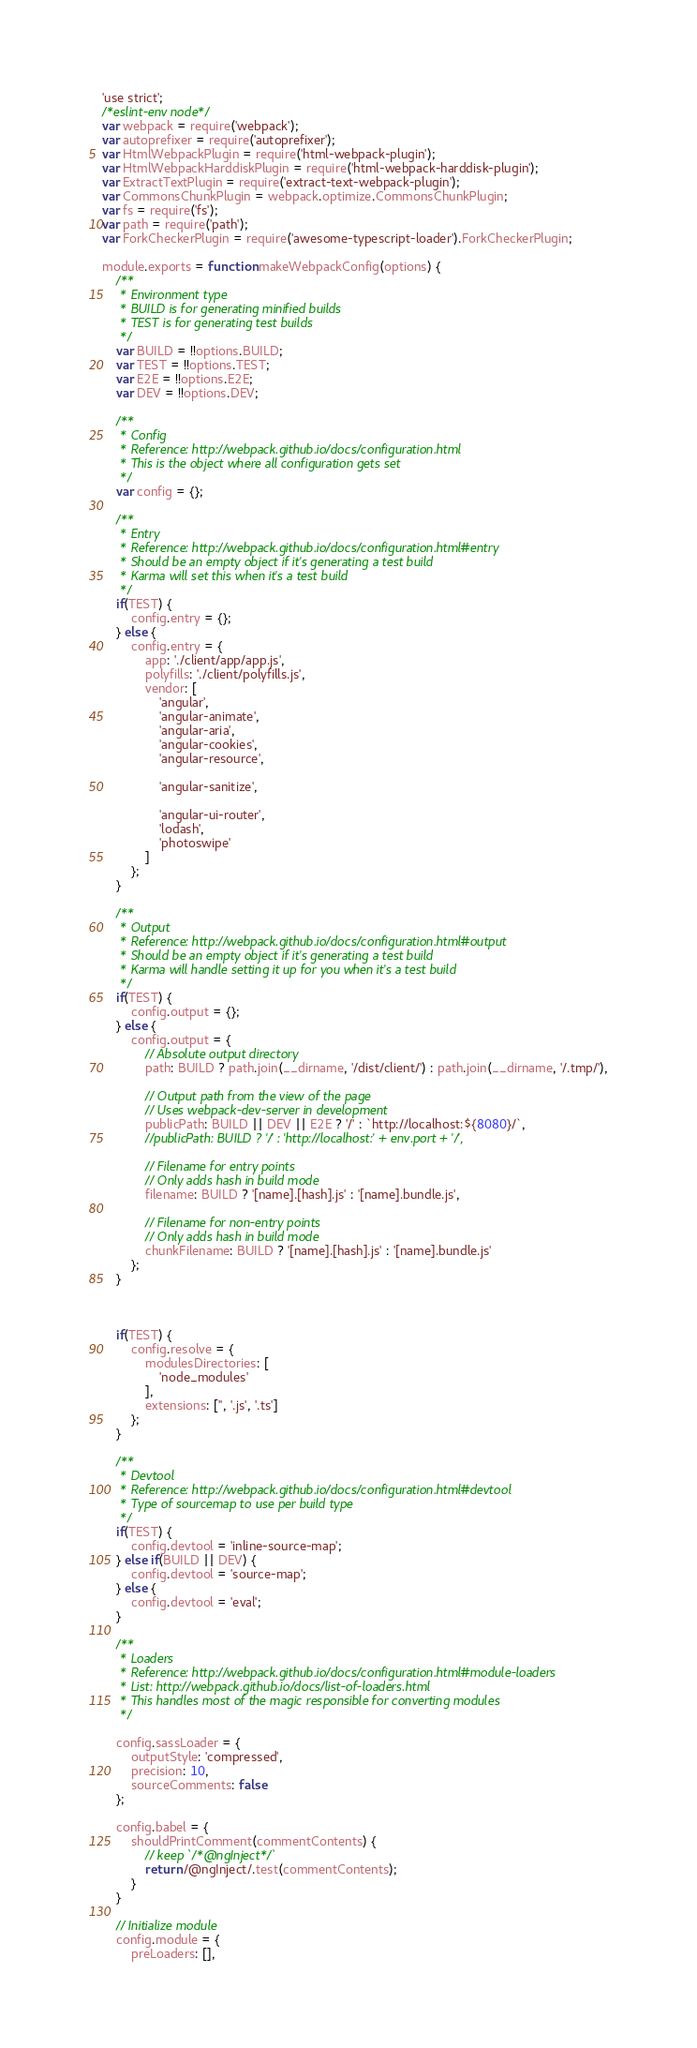Convert code to text. <code><loc_0><loc_0><loc_500><loc_500><_JavaScript_>'use strict';
/*eslint-env node*/
var webpack = require('webpack');
var autoprefixer = require('autoprefixer');
var HtmlWebpackPlugin = require('html-webpack-plugin');
var HtmlWebpackHarddiskPlugin = require('html-webpack-harddisk-plugin');
var ExtractTextPlugin = require('extract-text-webpack-plugin');
var CommonsChunkPlugin = webpack.optimize.CommonsChunkPlugin;
var fs = require('fs');
var path = require('path');
var ForkCheckerPlugin = require('awesome-typescript-loader').ForkCheckerPlugin;

module.exports = function makeWebpackConfig(options) {
    /**
     * Environment type
     * BUILD is for generating minified builds
     * TEST is for generating test builds
     */
    var BUILD = !!options.BUILD;
    var TEST = !!options.TEST;
    var E2E = !!options.E2E;
    var DEV = !!options.DEV;

    /**
     * Config
     * Reference: http://webpack.github.io/docs/configuration.html
     * This is the object where all configuration gets set
     */
    var config = {};

    /**
     * Entry
     * Reference: http://webpack.github.io/docs/configuration.html#entry
     * Should be an empty object if it's generating a test build
     * Karma will set this when it's a test build
     */
    if(TEST) {
        config.entry = {};
    } else {
        config.entry = {
            app: './client/app/app.js',
            polyfills: './client/polyfills.js',
            vendor: [
                'angular',
                'angular-animate',
                'angular-aria',
                'angular-cookies',
                'angular-resource',

                'angular-sanitize',

                'angular-ui-router',
                'lodash',
                'photoswipe'
            ]
        };
    }

    /**
     * Output
     * Reference: http://webpack.github.io/docs/configuration.html#output
     * Should be an empty object if it's generating a test build
     * Karma will handle setting it up for you when it's a test build
     */
    if(TEST) {
        config.output = {};
    } else {
        config.output = {
            // Absolute output directory
            path: BUILD ? path.join(__dirname, '/dist/client/') : path.join(__dirname, '/.tmp/'),

            // Output path from the view of the page
            // Uses webpack-dev-server in development
            publicPath: BUILD || DEV || E2E ? '/' : `http://localhost:${8080}/`,
            //publicPath: BUILD ? '/' : 'http://localhost:' + env.port + '/',

            // Filename for entry points
            // Only adds hash in build mode
            filename: BUILD ? '[name].[hash].js' : '[name].bundle.js',

            // Filename for non-entry points
            // Only adds hash in build mode
            chunkFilename: BUILD ? '[name].[hash].js' : '[name].bundle.js'
        };
    }



    if(TEST) {
        config.resolve = {
            modulesDirectories: [
                'node_modules'
            ],
            extensions: ['', '.js', '.ts']
        };
    }

    /**
     * Devtool
     * Reference: http://webpack.github.io/docs/configuration.html#devtool
     * Type of sourcemap to use per build type
     */
    if(TEST) {
        config.devtool = 'inline-source-map';
    } else if(BUILD || DEV) {
        config.devtool = 'source-map';
    } else {
        config.devtool = 'eval';
    }

    /**
     * Loaders
     * Reference: http://webpack.github.io/docs/configuration.html#module-loaders
     * List: http://webpack.github.io/docs/list-of-loaders.html
     * This handles most of the magic responsible for converting modules
     */

    config.sassLoader = {
        outputStyle: 'compressed',
        precision: 10,
        sourceComments: false
    };

    config.babel = {
        shouldPrintComment(commentContents) {
            // keep `/*@ngInject*/`
            return /@ngInject/.test(commentContents);
        }
    }

    // Initialize module
    config.module = {
        preLoaders: [],</code> 